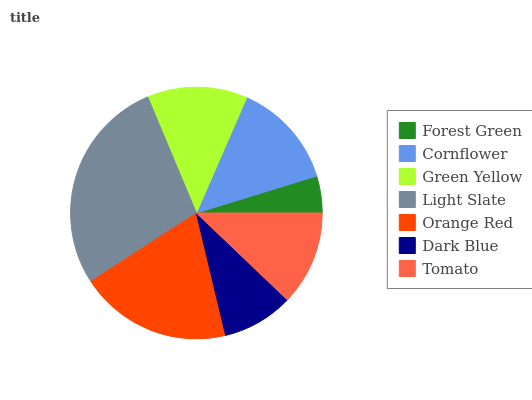Is Forest Green the minimum?
Answer yes or no. Yes. Is Light Slate the maximum?
Answer yes or no. Yes. Is Cornflower the minimum?
Answer yes or no. No. Is Cornflower the maximum?
Answer yes or no. No. Is Cornflower greater than Forest Green?
Answer yes or no. Yes. Is Forest Green less than Cornflower?
Answer yes or no. Yes. Is Forest Green greater than Cornflower?
Answer yes or no. No. Is Cornflower less than Forest Green?
Answer yes or no. No. Is Green Yellow the high median?
Answer yes or no. Yes. Is Green Yellow the low median?
Answer yes or no. Yes. Is Cornflower the high median?
Answer yes or no. No. Is Cornflower the low median?
Answer yes or no. No. 